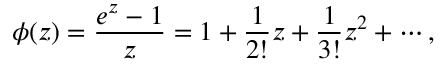Convert formula to latex. <formula><loc_0><loc_0><loc_500><loc_500>\phi ( z ) = { \frac { e ^ { z } - 1 } { z } } = 1 + { \frac { 1 } { 2 ! } } z + { \frac { 1 } { 3 ! } } z ^ { 2 } + \cdots ,</formula> 